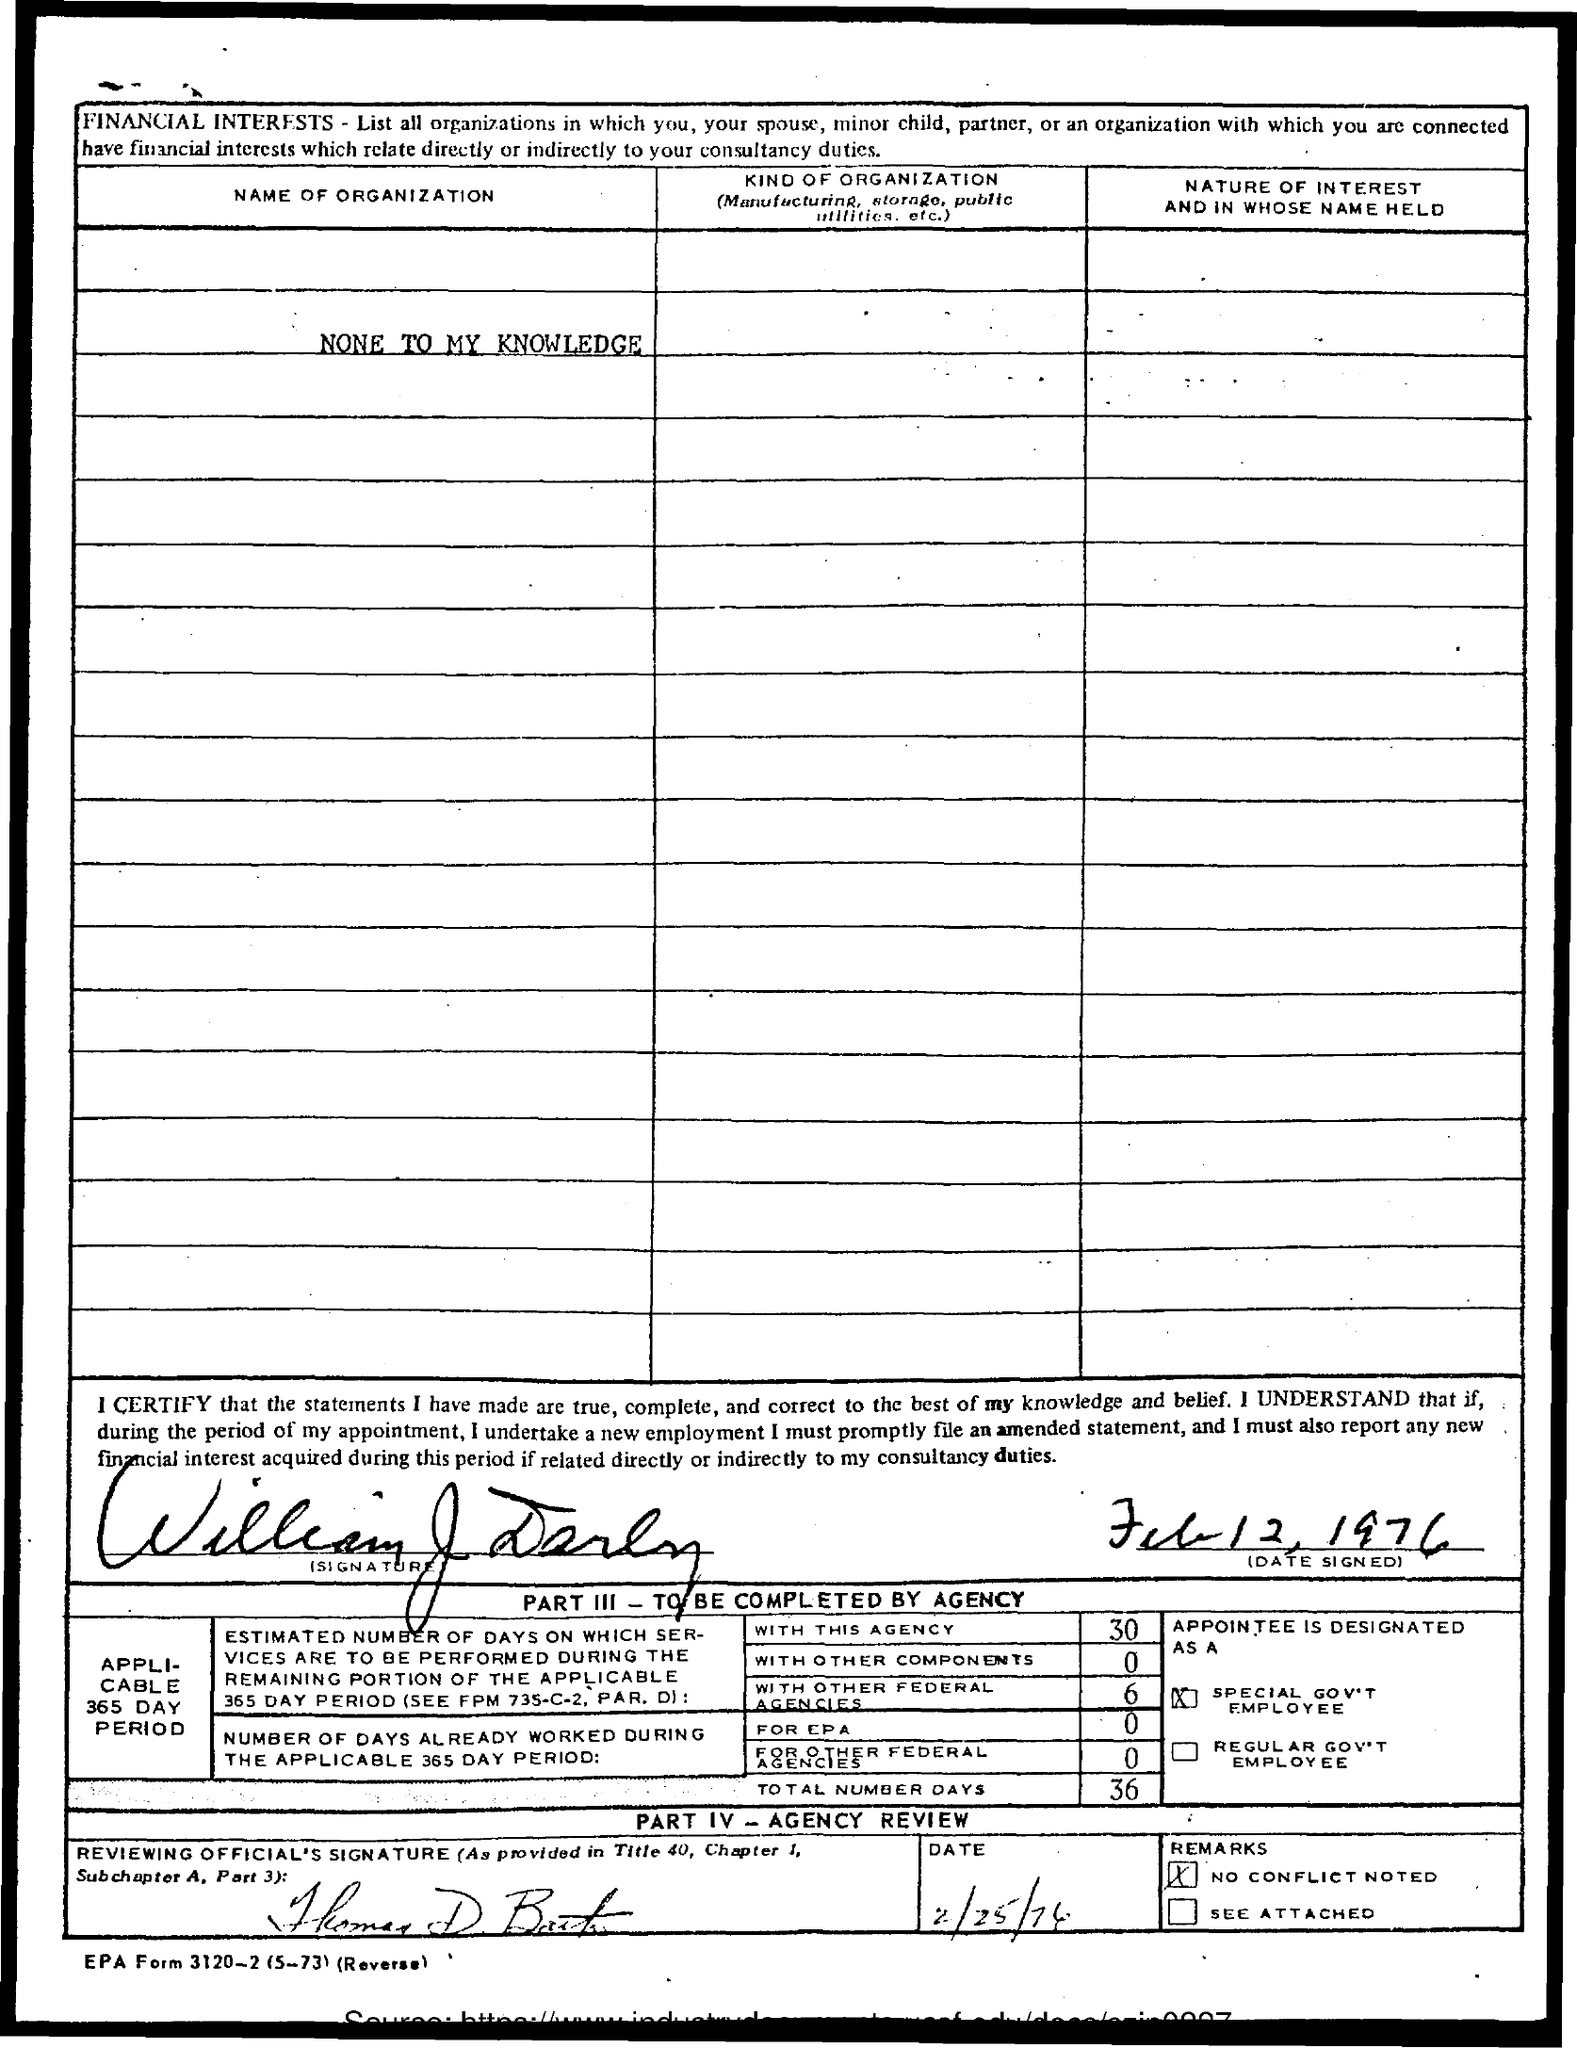What is the date of the signing?
Give a very brief answer. Feb 12, 1976. Who signed the document?
Offer a terse response. William J Darby. 